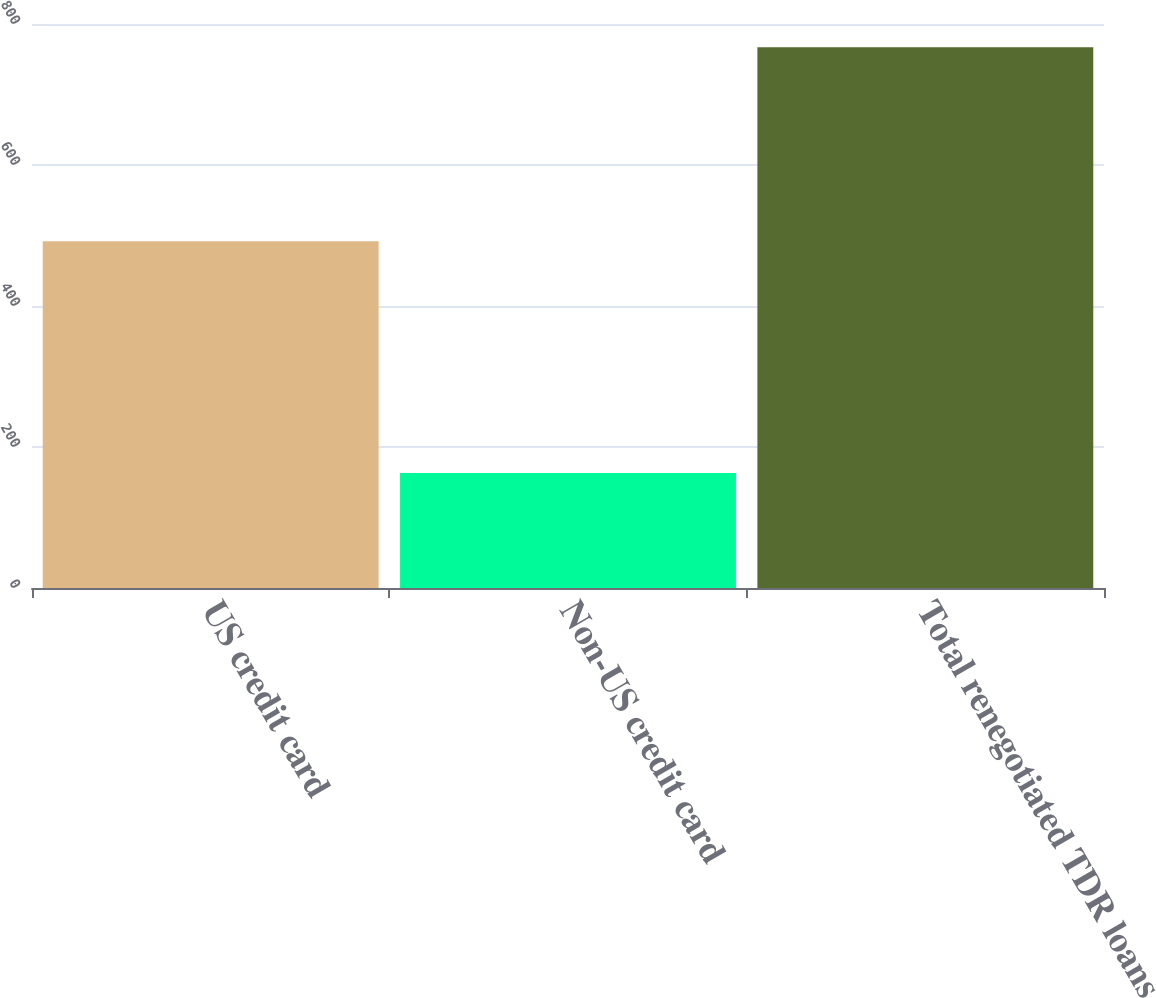Convert chart to OTSL. <chart><loc_0><loc_0><loc_500><loc_500><bar_chart><fcel>US credit card<fcel>Non-US credit card<fcel>Total renegotiated TDR loans<nl><fcel>492<fcel>163<fcel>767<nl></chart> 